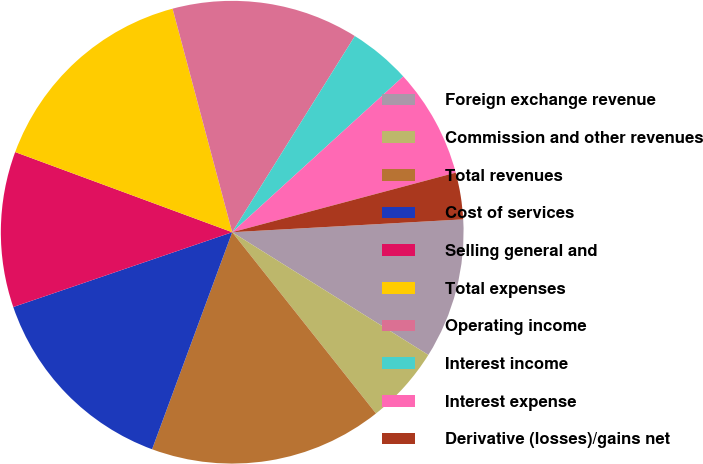<chart> <loc_0><loc_0><loc_500><loc_500><pie_chart><fcel>Foreign exchange revenue<fcel>Commission and other revenues<fcel>Total revenues<fcel>Cost of services<fcel>Selling general and<fcel>Total expenses<fcel>Operating income<fcel>Interest income<fcel>Interest expense<fcel>Derivative (losses)/gains net<nl><fcel>9.78%<fcel>5.43%<fcel>16.3%<fcel>14.13%<fcel>10.87%<fcel>15.22%<fcel>13.04%<fcel>4.35%<fcel>7.61%<fcel>3.26%<nl></chart> 